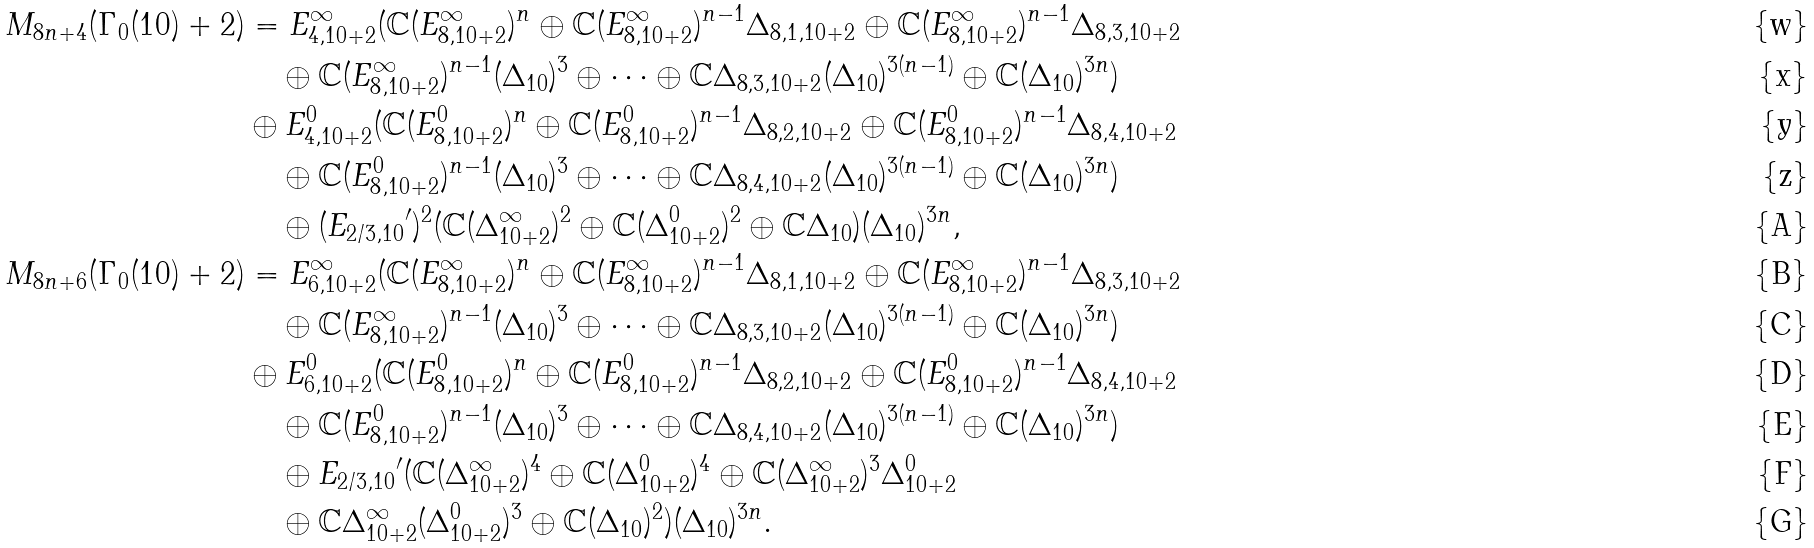Convert formula to latex. <formula><loc_0><loc_0><loc_500><loc_500>M _ { 8 n + 4 } ( \Gamma _ { 0 } ( 1 0 ) + 2 ) & = E _ { 4 , 1 0 + 2 } ^ { \infty } ( \mathbb { C } ( E _ { 8 , 1 0 + 2 } ^ { \infty } ) ^ { n } \oplus \mathbb { C } ( E _ { 8 , 1 0 + 2 } ^ { \infty } ) ^ { n - 1 } \Delta _ { 8 , 1 , 1 0 + 2 } \oplus \mathbb { C } ( E _ { 8 , 1 0 + 2 } ^ { \infty } ) ^ { n - 1 } \Delta _ { 8 , 3 , 1 0 + 2 } \\ & \quad \oplus \mathbb { C } ( E _ { 8 , 1 0 + 2 } ^ { \infty } ) ^ { n - 1 } ( \Delta _ { 1 0 } ) ^ { 3 } \oplus \cdots \oplus \mathbb { C } \Delta _ { 8 , 3 , 1 0 + 2 } ( \Delta _ { 1 0 } ) ^ { 3 ( n - 1 ) } \oplus \mathbb { C } ( \Delta _ { 1 0 } ) ^ { 3 n } ) \\ & \oplus E _ { 4 , 1 0 + 2 } ^ { 0 } ( \mathbb { C } ( E _ { 8 , 1 0 + 2 } ^ { 0 } ) ^ { n } \oplus \mathbb { C } ( E _ { 8 , 1 0 + 2 } ^ { 0 } ) ^ { n - 1 } \Delta _ { 8 , 2 , 1 0 + 2 } \oplus \mathbb { C } ( E _ { 8 , 1 0 + 2 } ^ { 0 } ) ^ { n - 1 } \Delta _ { 8 , 4 , 1 0 + 2 } \\ & \quad \oplus \mathbb { C } ( E _ { 8 , 1 0 + 2 } ^ { 0 } ) ^ { n - 1 } ( \Delta _ { 1 0 } ) ^ { 3 } \oplus \cdots \oplus \mathbb { C } \Delta _ { 8 , 4 , 1 0 + 2 } ( \Delta _ { 1 0 } ) ^ { 3 ( n - 1 ) } \oplus \mathbb { C } ( \Delta _ { 1 0 } ) ^ { 3 n } ) \\ & \quad \oplus ( { E _ { 2 / 3 , 1 0 } } ^ { \prime } ) ^ { 2 } ( \mathbb { C } ( \Delta _ { 1 0 + 2 } ^ { \infty } ) ^ { 2 } \oplus \mathbb { C } ( \Delta _ { 1 0 + 2 } ^ { 0 } ) ^ { 2 } \oplus \mathbb { C } \Delta _ { 1 0 } ) ( \Delta _ { 1 0 } ) ^ { 3 n } , \\ M _ { 8 n + 6 } ( \Gamma _ { 0 } ( 1 0 ) + 2 ) & = E _ { 6 , 1 0 + 2 } ^ { \infty } ( \mathbb { C } ( E _ { 8 , 1 0 + 2 } ^ { \infty } ) ^ { n } \oplus \mathbb { C } ( E _ { 8 , 1 0 + 2 } ^ { \infty } ) ^ { n - 1 } \Delta _ { 8 , 1 , 1 0 + 2 } \oplus \mathbb { C } ( E _ { 8 , 1 0 + 2 } ^ { \infty } ) ^ { n - 1 } \Delta _ { 8 , 3 , 1 0 + 2 } \\ & \quad \oplus \mathbb { C } ( E _ { 8 , 1 0 + 2 } ^ { \infty } ) ^ { n - 1 } ( \Delta _ { 1 0 } ) ^ { 3 } \oplus \cdots \oplus \mathbb { C } \Delta _ { 8 , 3 , 1 0 + 2 } ( \Delta _ { 1 0 } ) ^ { 3 ( n - 1 ) } \oplus \mathbb { C } ( \Delta _ { 1 0 } ) ^ { 3 n } ) \\ & \oplus E _ { 6 , 1 0 + 2 } ^ { 0 } ( \mathbb { C } ( E _ { 8 , 1 0 + 2 } ^ { 0 } ) ^ { n } \oplus \mathbb { C } ( E _ { 8 , 1 0 + 2 } ^ { 0 } ) ^ { n - 1 } \Delta _ { 8 , 2 , 1 0 + 2 } \oplus \mathbb { C } ( E _ { 8 , 1 0 + 2 } ^ { 0 } ) ^ { n - 1 } \Delta _ { 8 , 4 , 1 0 + 2 } \\ & \quad \oplus \mathbb { C } ( E _ { 8 , 1 0 + 2 } ^ { 0 } ) ^ { n - 1 } ( \Delta _ { 1 0 } ) ^ { 3 } \oplus \cdots \oplus \mathbb { C } \Delta _ { 8 , 4 , 1 0 + 2 } ( \Delta _ { 1 0 } ) ^ { 3 ( n - 1 ) } \oplus \mathbb { C } ( \Delta _ { 1 0 } ) ^ { 3 n } ) \\ & \quad \oplus { E _ { 2 / 3 , 1 0 } } ^ { \prime } ( \mathbb { C } ( \Delta _ { 1 0 + 2 } ^ { \infty } ) ^ { 4 } \oplus \mathbb { C } ( \Delta _ { 1 0 + 2 } ^ { 0 } ) ^ { 4 } \oplus \mathbb { C } ( \Delta _ { 1 0 + 2 } ^ { \infty } ) ^ { 3 } \Delta _ { 1 0 + 2 } ^ { 0 } \\ & \quad \oplus \mathbb { C } \Delta _ { 1 0 + 2 } ^ { \infty } ( \Delta _ { 1 0 + 2 } ^ { 0 } ) ^ { 3 } \oplus \mathbb { C } ( \Delta _ { 1 0 } ) ^ { 2 } ) ( \Delta _ { 1 0 } ) ^ { 3 n } .</formula> 